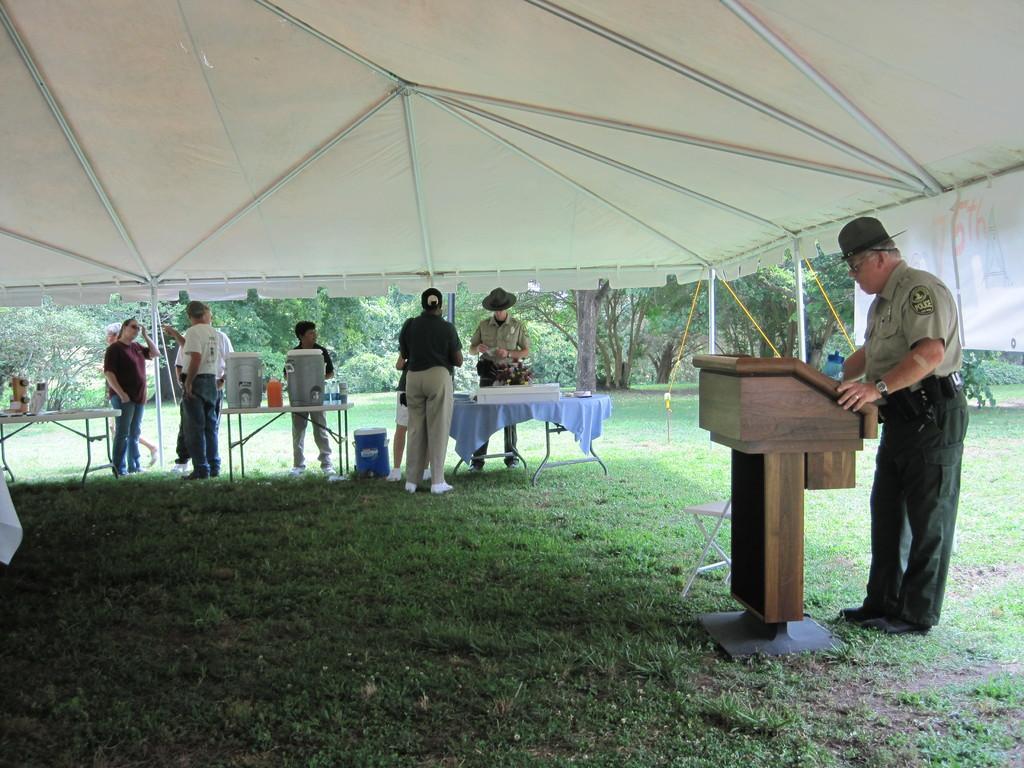In one or two sentences, can you explain what this image depicts? In this image I can see the group of people standing. Among them one person is wearing uniform and he is standing in front of the podium. There are two drums on the table. And these people are under the tent and I can also see some of the trees outside. 